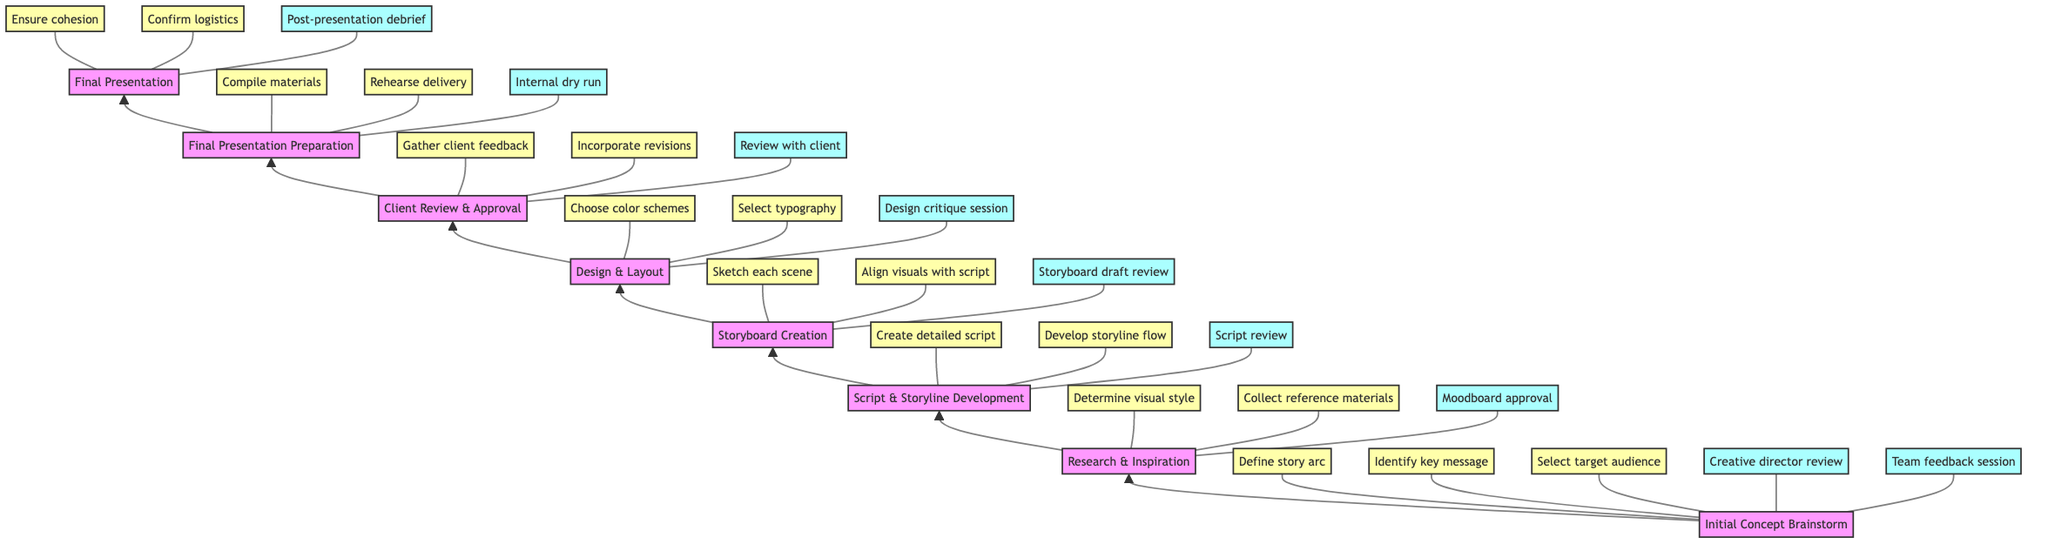What is the first step in the flow chart? The flow chart begins with "Initial Concept Brainstorm," which is the first node in the diagram.
Answer: Initial Concept Brainstorm How many feedback loops are there in the "Research & Inspiration" step? The "Research & Inspiration" step has one feedback loop indicated in the diagram: "Moodboard approval." Thus, there is a single feedback loop for this node.
Answer: 1 What is the key decision point for the "Client Review & Approval" step? The "Client Review & Approval" step has three key decision points: "Gather client feedback," "Incorporate client revisions," and "Final client sign-off." Thus, the number of key decision points is three.
Answer: 3 Which node directly precedes "Final Presentation Preparation"? The node directly preceding "Final Presentation Preparation" is "Client Review & Approval." This relationship is represented by a downward flow from one node to the next.
Answer: Client Review & Approval What are the two final key decision points before the final presentation? The final decision points before the presentation, which is represented by the last node in the flow, are "Ensure cohesion" and "Confirm logistics." These are outlined within the "Final Presentation" step.
Answer: Ensure cohesion, Confirm logistics What feedback loop is associated with the "Storyboard Creation" step? In the "Storyboard Creation" step, the feedback loop is "Storyboard draft review." This indicates an iterative process where reviews help refine the storyboard.
Answer: Storyboard draft review How many total steps are there in the flow chart? The flow includes eight distinct steps from top to bottom, starting with the initial concept and culminating in the final presentation. This total includes all represented processes.
Answer: 8 What is the last step in the flow chart? The last step in the flow chart, indicated at the top of the flow, is "Final Presentation." This is the concluding action where the visual storyboard is delivered.
Answer: Final Presentation 